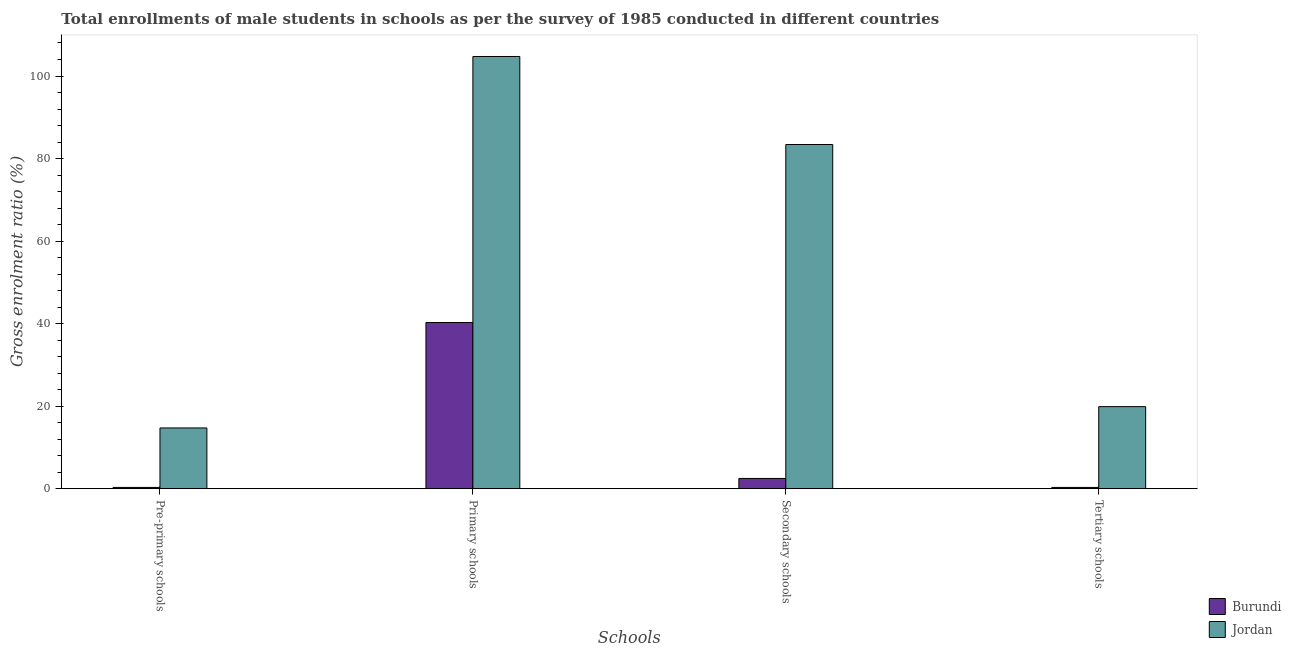How many different coloured bars are there?
Provide a short and direct response. 2. How many bars are there on the 2nd tick from the left?
Offer a terse response. 2. How many bars are there on the 4th tick from the right?
Provide a short and direct response. 2. What is the label of the 1st group of bars from the left?
Your response must be concise. Pre-primary schools. What is the gross enrolment ratio(male) in primary schools in Jordan?
Give a very brief answer. 104.73. Across all countries, what is the maximum gross enrolment ratio(male) in pre-primary schools?
Your answer should be very brief. 14.71. Across all countries, what is the minimum gross enrolment ratio(male) in pre-primary schools?
Your response must be concise. 0.3. In which country was the gross enrolment ratio(male) in pre-primary schools maximum?
Keep it short and to the point. Jordan. In which country was the gross enrolment ratio(male) in secondary schools minimum?
Provide a short and direct response. Burundi. What is the total gross enrolment ratio(male) in pre-primary schools in the graph?
Offer a terse response. 15.02. What is the difference between the gross enrolment ratio(male) in tertiary schools in Burundi and that in Jordan?
Your response must be concise. -19.57. What is the difference between the gross enrolment ratio(male) in secondary schools in Burundi and the gross enrolment ratio(male) in pre-primary schools in Jordan?
Your response must be concise. -12.24. What is the average gross enrolment ratio(male) in tertiary schools per country?
Give a very brief answer. 10.09. What is the difference between the gross enrolment ratio(male) in pre-primary schools and gross enrolment ratio(male) in secondary schools in Jordan?
Your response must be concise. -68.68. In how many countries, is the gross enrolment ratio(male) in secondary schools greater than 12 %?
Make the answer very short. 1. What is the ratio of the gross enrolment ratio(male) in tertiary schools in Burundi to that in Jordan?
Ensure brevity in your answer.  0.02. Is the gross enrolment ratio(male) in pre-primary schools in Burundi less than that in Jordan?
Provide a succinct answer. Yes. Is the difference between the gross enrolment ratio(male) in tertiary schools in Burundi and Jordan greater than the difference between the gross enrolment ratio(male) in pre-primary schools in Burundi and Jordan?
Make the answer very short. No. What is the difference between the highest and the second highest gross enrolment ratio(male) in pre-primary schools?
Offer a very short reply. 14.41. What is the difference between the highest and the lowest gross enrolment ratio(male) in primary schools?
Offer a very short reply. 64.47. Is the sum of the gross enrolment ratio(male) in pre-primary schools in Burundi and Jordan greater than the maximum gross enrolment ratio(male) in primary schools across all countries?
Provide a succinct answer. No. Is it the case that in every country, the sum of the gross enrolment ratio(male) in tertiary schools and gross enrolment ratio(male) in secondary schools is greater than the sum of gross enrolment ratio(male) in primary schools and gross enrolment ratio(male) in pre-primary schools?
Keep it short and to the point. No. What does the 1st bar from the left in Primary schools represents?
Provide a short and direct response. Burundi. What does the 1st bar from the right in Pre-primary schools represents?
Offer a very short reply. Jordan. Are all the bars in the graph horizontal?
Offer a very short reply. No. How many countries are there in the graph?
Offer a terse response. 2. What is the difference between two consecutive major ticks on the Y-axis?
Ensure brevity in your answer.  20. Does the graph contain any zero values?
Provide a succinct answer. No. Does the graph contain grids?
Ensure brevity in your answer.  No. What is the title of the graph?
Keep it short and to the point. Total enrollments of male students in schools as per the survey of 1985 conducted in different countries. Does "St. Martin (French part)" appear as one of the legend labels in the graph?
Ensure brevity in your answer.  No. What is the label or title of the X-axis?
Give a very brief answer. Schools. What is the Gross enrolment ratio (%) in Burundi in Pre-primary schools?
Your response must be concise. 0.3. What is the Gross enrolment ratio (%) of Jordan in Pre-primary schools?
Make the answer very short. 14.71. What is the Gross enrolment ratio (%) in Burundi in Primary schools?
Your answer should be compact. 40.26. What is the Gross enrolment ratio (%) of Jordan in Primary schools?
Make the answer very short. 104.73. What is the Gross enrolment ratio (%) of Burundi in Secondary schools?
Make the answer very short. 2.48. What is the Gross enrolment ratio (%) in Jordan in Secondary schools?
Ensure brevity in your answer.  83.39. What is the Gross enrolment ratio (%) in Burundi in Tertiary schools?
Your answer should be very brief. 0.3. What is the Gross enrolment ratio (%) of Jordan in Tertiary schools?
Provide a succinct answer. 19.88. Across all Schools, what is the maximum Gross enrolment ratio (%) in Burundi?
Ensure brevity in your answer.  40.26. Across all Schools, what is the maximum Gross enrolment ratio (%) of Jordan?
Offer a terse response. 104.73. Across all Schools, what is the minimum Gross enrolment ratio (%) of Burundi?
Give a very brief answer. 0.3. Across all Schools, what is the minimum Gross enrolment ratio (%) of Jordan?
Provide a short and direct response. 14.71. What is the total Gross enrolment ratio (%) in Burundi in the graph?
Provide a short and direct response. 43.34. What is the total Gross enrolment ratio (%) in Jordan in the graph?
Offer a terse response. 222.71. What is the difference between the Gross enrolment ratio (%) of Burundi in Pre-primary schools and that in Primary schools?
Your answer should be very brief. -39.96. What is the difference between the Gross enrolment ratio (%) in Jordan in Pre-primary schools and that in Primary schools?
Make the answer very short. -90.01. What is the difference between the Gross enrolment ratio (%) of Burundi in Pre-primary schools and that in Secondary schools?
Offer a very short reply. -2.18. What is the difference between the Gross enrolment ratio (%) in Jordan in Pre-primary schools and that in Secondary schools?
Ensure brevity in your answer.  -68.68. What is the difference between the Gross enrolment ratio (%) in Burundi in Pre-primary schools and that in Tertiary schools?
Your answer should be compact. -0. What is the difference between the Gross enrolment ratio (%) in Jordan in Pre-primary schools and that in Tertiary schools?
Offer a terse response. -5.16. What is the difference between the Gross enrolment ratio (%) in Burundi in Primary schools and that in Secondary schools?
Offer a very short reply. 37.78. What is the difference between the Gross enrolment ratio (%) of Jordan in Primary schools and that in Secondary schools?
Keep it short and to the point. 21.33. What is the difference between the Gross enrolment ratio (%) in Burundi in Primary schools and that in Tertiary schools?
Keep it short and to the point. 39.96. What is the difference between the Gross enrolment ratio (%) of Jordan in Primary schools and that in Tertiary schools?
Provide a succinct answer. 84.85. What is the difference between the Gross enrolment ratio (%) in Burundi in Secondary schools and that in Tertiary schools?
Ensure brevity in your answer.  2.17. What is the difference between the Gross enrolment ratio (%) of Jordan in Secondary schools and that in Tertiary schools?
Your answer should be very brief. 63.52. What is the difference between the Gross enrolment ratio (%) in Burundi in Pre-primary schools and the Gross enrolment ratio (%) in Jordan in Primary schools?
Ensure brevity in your answer.  -104.43. What is the difference between the Gross enrolment ratio (%) of Burundi in Pre-primary schools and the Gross enrolment ratio (%) of Jordan in Secondary schools?
Offer a very short reply. -83.09. What is the difference between the Gross enrolment ratio (%) of Burundi in Pre-primary schools and the Gross enrolment ratio (%) of Jordan in Tertiary schools?
Your answer should be compact. -19.57. What is the difference between the Gross enrolment ratio (%) of Burundi in Primary schools and the Gross enrolment ratio (%) of Jordan in Secondary schools?
Give a very brief answer. -43.13. What is the difference between the Gross enrolment ratio (%) of Burundi in Primary schools and the Gross enrolment ratio (%) of Jordan in Tertiary schools?
Your answer should be very brief. 20.39. What is the difference between the Gross enrolment ratio (%) in Burundi in Secondary schools and the Gross enrolment ratio (%) in Jordan in Tertiary schools?
Give a very brief answer. -17.4. What is the average Gross enrolment ratio (%) of Burundi per Schools?
Provide a short and direct response. 10.84. What is the average Gross enrolment ratio (%) in Jordan per Schools?
Your response must be concise. 55.68. What is the difference between the Gross enrolment ratio (%) of Burundi and Gross enrolment ratio (%) of Jordan in Pre-primary schools?
Your response must be concise. -14.41. What is the difference between the Gross enrolment ratio (%) of Burundi and Gross enrolment ratio (%) of Jordan in Primary schools?
Offer a very short reply. -64.47. What is the difference between the Gross enrolment ratio (%) of Burundi and Gross enrolment ratio (%) of Jordan in Secondary schools?
Your response must be concise. -80.92. What is the difference between the Gross enrolment ratio (%) of Burundi and Gross enrolment ratio (%) of Jordan in Tertiary schools?
Keep it short and to the point. -19.57. What is the ratio of the Gross enrolment ratio (%) in Burundi in Pre-primary schools to that in Primary schools?
Ensure brevity in your answer.  0.01. What is the ratio of the Gross enrolment ratio (%) in Jordan in Pre-primary schools to that in Primary schools?
Provide a short and direct response. 0.14. What is the ratio of the Gross enrolment ratio (%) of Burundi in Pre-primary schools to that in Secondary schools?
Offer a very short reply. 0.12. What is the ratio of the Gross enrolment ratio (%) of Jordan in Pre-primary schools to that in Secondary schools?
Your answer should be compact. 0.18. What is the ratio of the Gross enrolment ratio (%) in Burundi in Pre-primary schools to that in Tertiary schools?
Provide a short and direct response. 0.99. What is the ratio of the Gross enrolment ratio (%) in Jordan in Pre-primary schools to that in Tertiary schools?
Your answer should be very brief. 0.74. What is the ratio of the Gross enrolment ratio (%) in Burundi in Primary schools to that in Secondary schools?
Make the answer very short. 16.25. What is the ratio of the Gross enrolment ratio (%) of Jordan in Primary schools to that in Secondary schools?
Make the answer very short. 1.26. What is the ratio of the Gross enrolment ratio (%) in Burundi in Primary schools to that in Tertiary schools?
Your answer should be very brief. 132.9. What is the ratio of the Gross enrolment ratio (%) in Jordan in Primary schools to that in Tertiary schools?
Your response must be concise. 5.27. What is the ratio of the Gross enrolment ratio (%) of Burundi in Secondary schools to that in Tertiary schools?
Your answer should be compact. 8.18. What is the ratio of the Gross enrolment ratio (%) in Jordan in Secondary schools to that in Tertiary schools?
Provide a short and direct response. 4.2. What is the difference between the highest and the second highest Gross enrolment ratio (%) of Burundi?
Ensure brevity in your answer.  37.78. What is the difference between the highest and the second highest Gross enrolment ratio (%) of Jordan?
Your answer should be very brief. 21.33. What is the difference between the highest and the lowest Gross enrolment ratio (%) in Burundi?
Make the answer very short. 39.96. What is the difference between the highest and the lowest Gross enrolment ratio (%) of Jordan?
Provide a short and direct response. 90.01. 